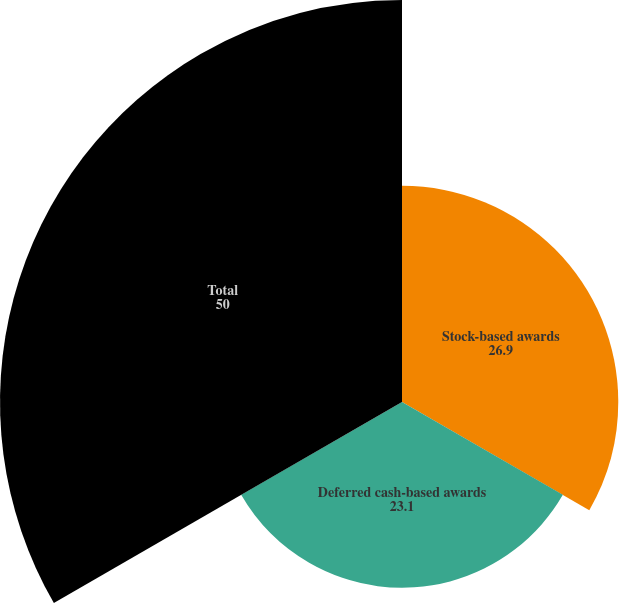Convert chart to OTSL. <chart><loc_0><loc_0><loc_500><loc_500><pie_chart><fcel>Stock-based awards<fcel>Deferred cash-based awards<fcel>Total<nl><fcel>26.9%<fcel>23.1%<fcel>50.0%<nl></chart> 